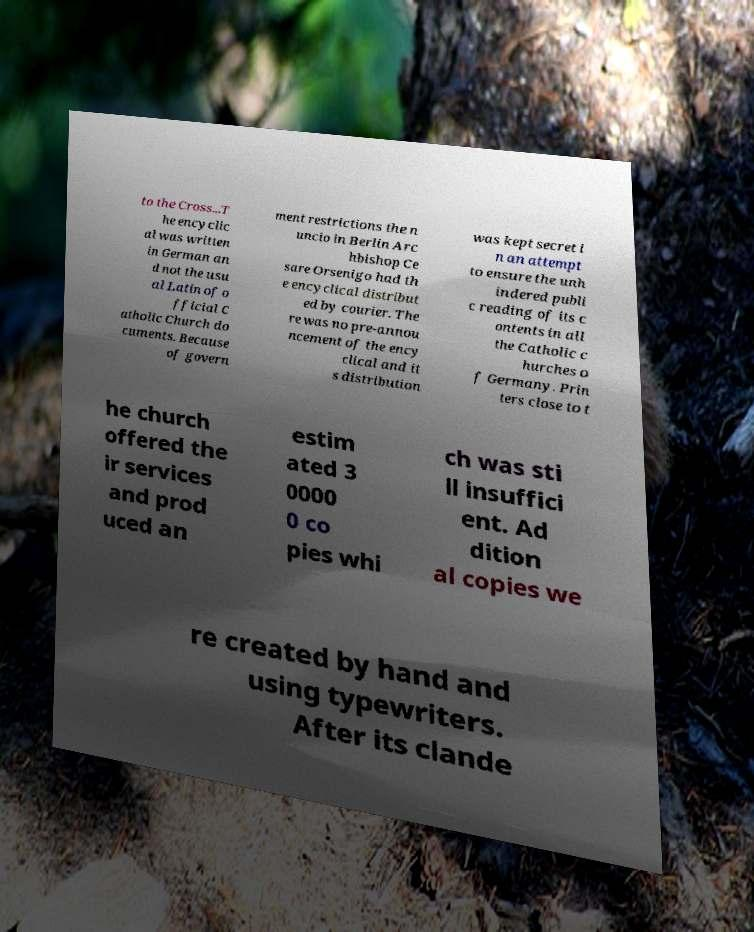Could you assist in decoding the text presented in this image and type it out clearly? to the Cross...T he encyclic al was written in German an d not the usu al Latin of o fficial C atholic Church do cuments. Because of govern ment restrictions the n uncio in Berlin Arc hbishop Ce sare Orsenigo had th e encyclical distribut ed by courier. The re was no pre-annou ncement of the ency clical and it s distribution was kept secret i n an attempt to ensure the unh indered publi c reading of its c ontents in all the Catholic c hurches o f Germany. Prin ters close to t he church offered the ir services and prod uced an estim ated 3 0000 0 co pies whi ch was sti ll insuffici ent. Ad dition al copies we re created by hand and using typewriters. After its clande 